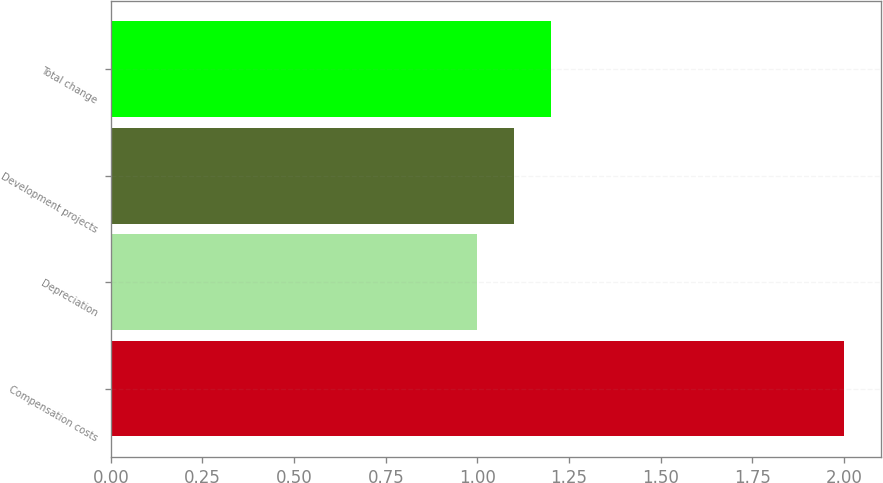<chart> <loc_0><loc_0><loc_500><loc_500><bar_chart><fcel>Compensation costs<fcel>Depreciation<fcel>Development projects<fcel>Total change<nl><fcel>2<fcel>1<fcel>1.1<fcel>1.2<nl></chart> 